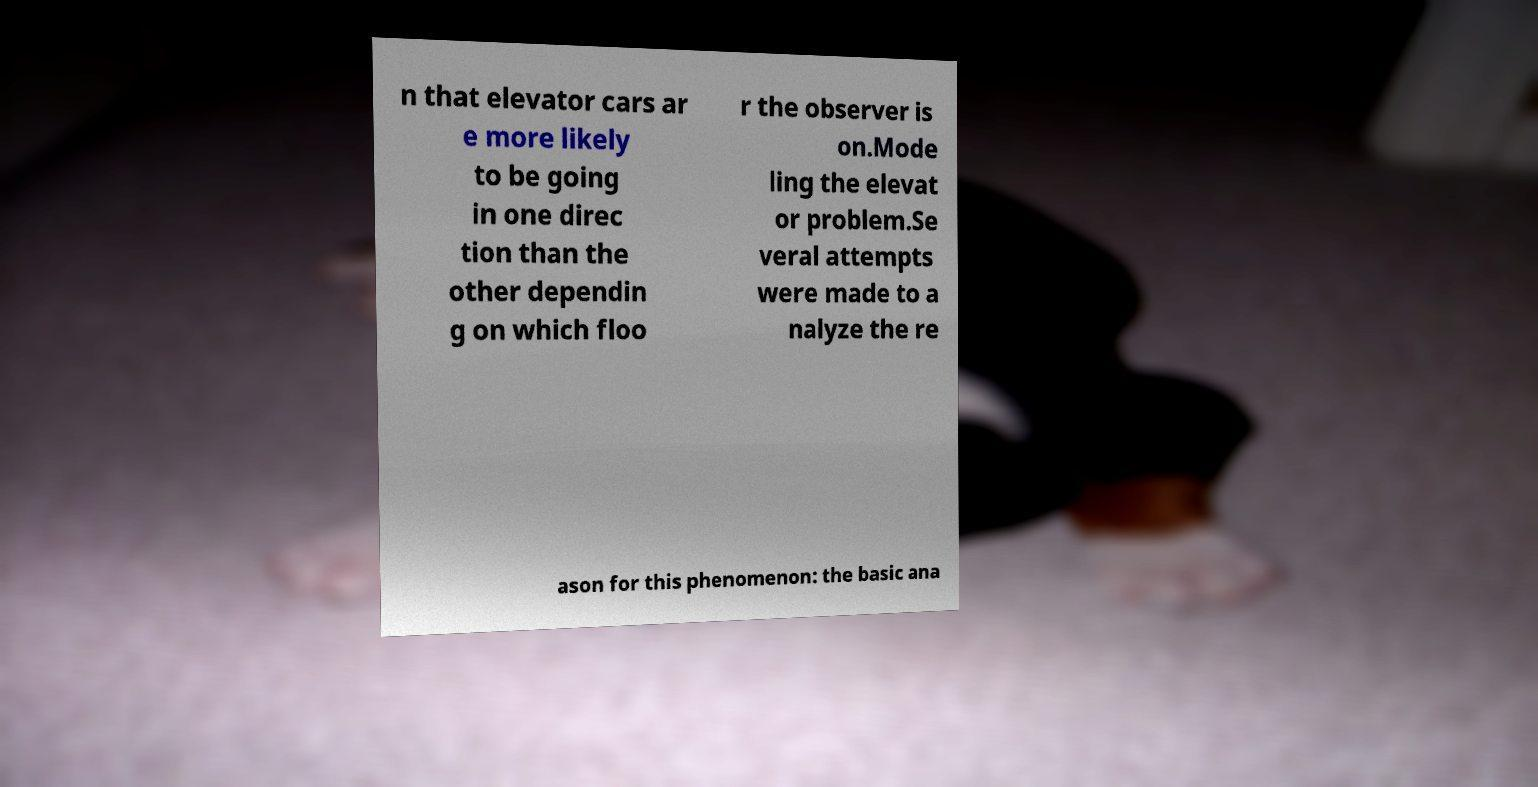Please identify and transcribe the text found in this image. n that elevator cars ar e more likely to be going in one direc tion than the other dependin g on which floo r the observer is on.Mode ling the elevat or problem.Se veral attempts were made to a nalyze the re ason for this phenomenon: the basic ana 